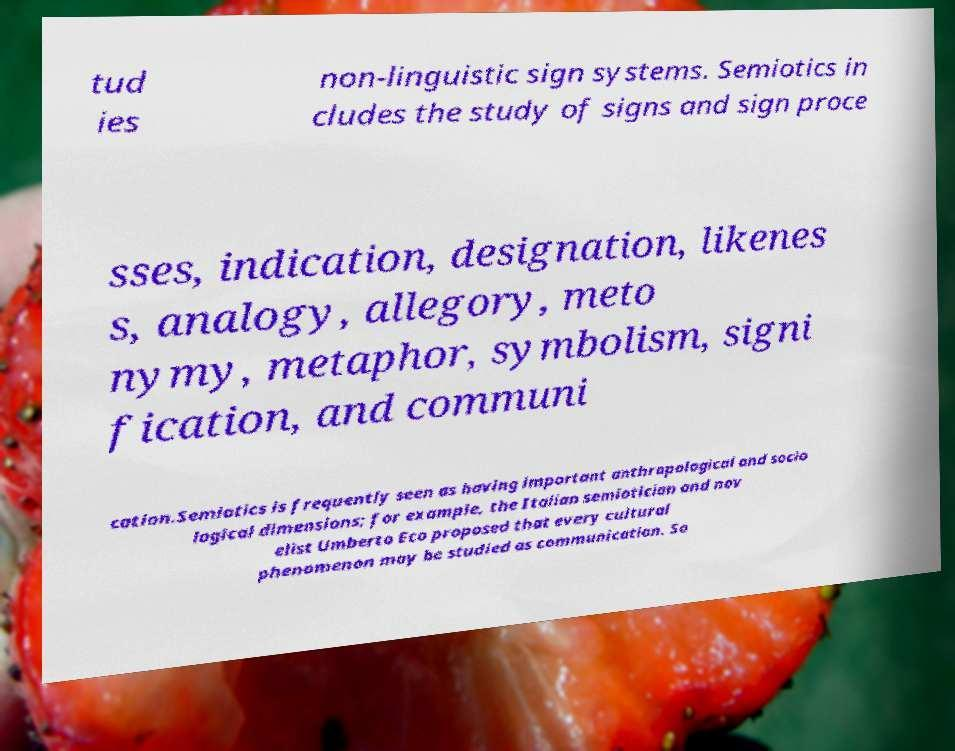Please identify and transcribe the text found in this image. tud ies non-linguistic sign systems. Semiotics in cludes the study of signs and sign proce sses, indication, designation, likenes s, analogy, allegory, meto nymy, metaphor, symbolism, signi fication, and communi cation.Semiotics is frequently seen as having important anthropological and socio logical dimensions; for example, the Italian semiotician and nov elist Umberto Eco proposed that every cultural phenomenon may be studied as communication. So 